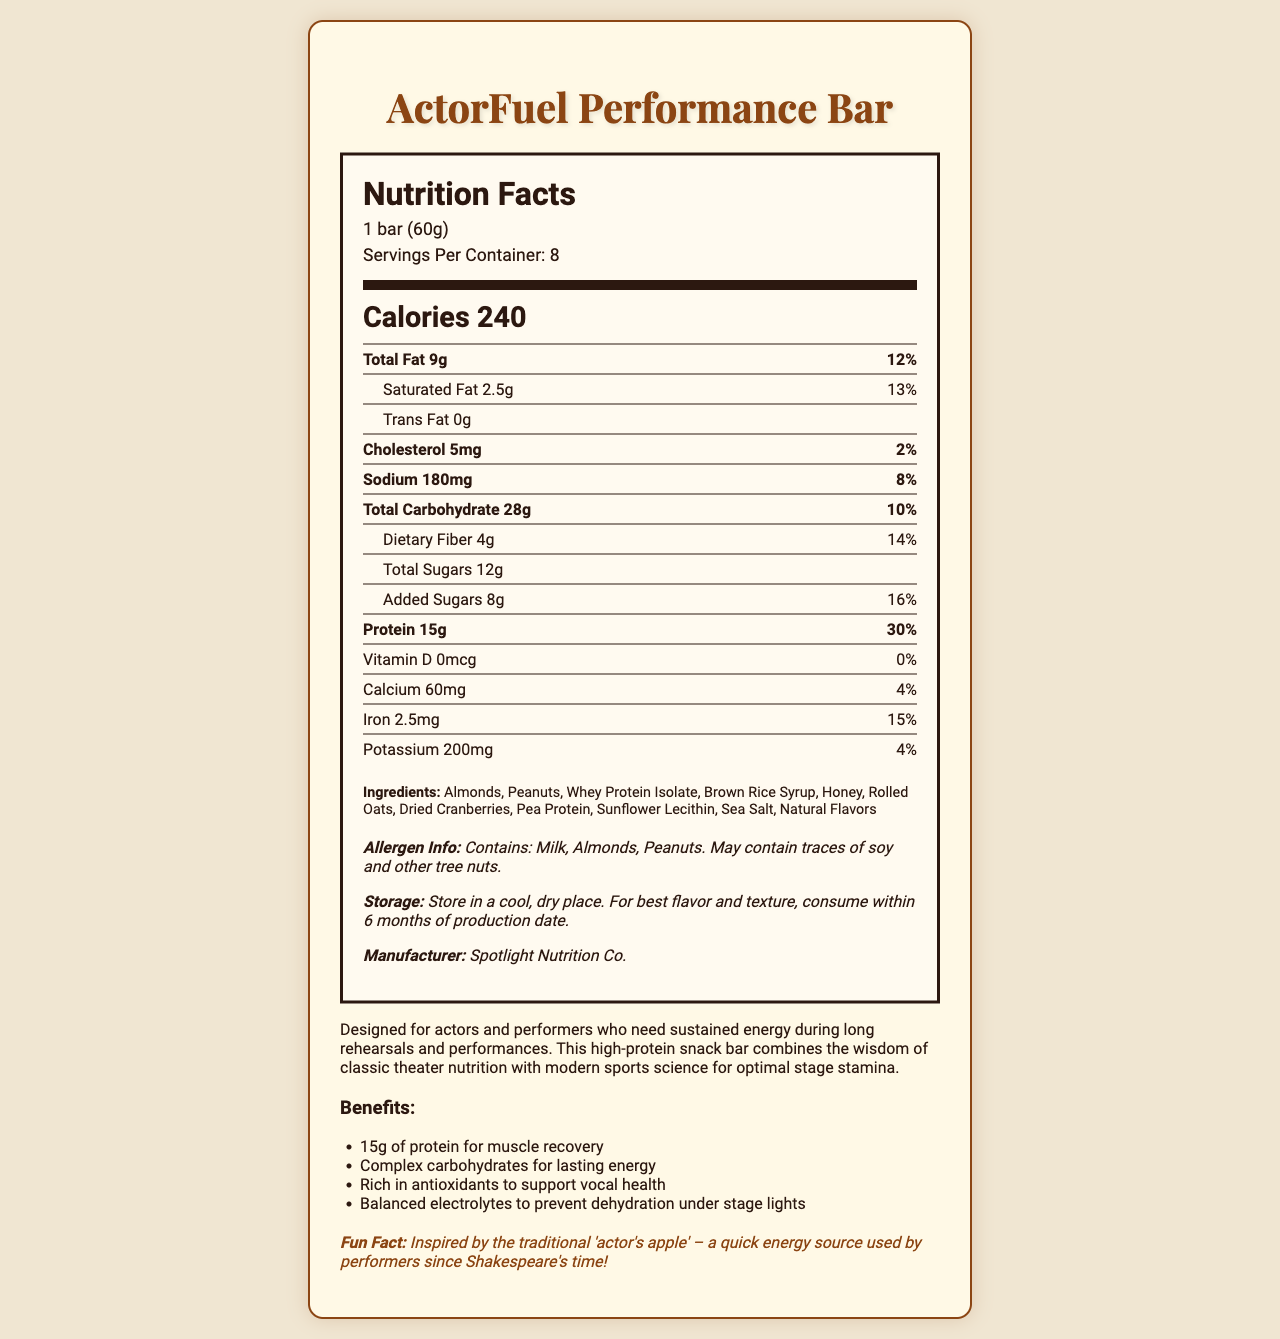what is the serving size for ActorFuel Performance Bar? The serving size is explicitly mentioned as "1 bar (60g)".
Answer: 1 bar (60g) how many calories are there in one serving of the ActorFuel Performance Bar? The document states that one serving contains 240 calories.
Answer: 240 calories how much protein is there in one ActorFuel Performance Bar? The protein content for one serving is listed as 15g.
Answer: 15g how many servings are there per container? The number of servings per container is clearly mentioned as 8.
Answer: 8 what percentage of daily value of dietary fiber does one bar contain? The document shows that one bar contains 14% of the daily value for dietary fiber.
Answer: 14% what is the amount of added sugars in one bar? One bar has 8 grams of added sugars.
Answer: 8g what allergens are present in the ActorFuel Performance Bar? The allergen information states that the bar contains milk, almonds, and peanuts, and may contain traces of soy and other tree nuts.
Answer: Milk, Almonds, Peanuts what is the storage instruction for ActorFuel Performance Bar? The storage instructions are to keep it in a cool, dry place and to consume within six months for the best flavor and texture.
Answer: Store in a cool, dry place. For best flavor and texture, consume within 6 months of production date. which ingredient is listed first in the ingredients of the ActorFuel Performance Bar? A. Honey B. Almonds C. Peanuts The first ingredient listed is Almonds.
Answer: B what is the total amount of fat in one bar? A. 9g B. 2.5g C. 0g The document states that the total fat content is 9g.
Answer: A is there any trans fat in the ActorFuel Performance Bar? The document explicitly states that there are 0 grams of trans fat.
Answer: No what are the benefits of the ActorFuel Performance Bar? The benefits section lists these points explicitly.
Answer: 15g of protein for muscle recovery, Complex carbohydrates for lasting energy, Rich in antioxidants to support vocal health, Balanced electrolytes to prevent dehydration under stage lights can you summarize the main idea of the document? This summary captures the key points such as nutritional details, intended benefits, and additional information found in the document.
Answer: The document provides detailed nutritional information about the ActorFuel Performance Bar, highlighting its high protein content, benefits for performers, ingredients, allergen info, and storage instructions. how many grams of dietary fiber are there in one serving? The document specifies that one serving contains 4 grams of dietary fiber.
Answer: 4g does one ActorFuel Performance Bar contain Vitamin D? The document states that the Vitamin D content is 0mcg, which means there is no Vitamin D in one bar.
Answer: No where is the ActorFuel Performance Bar manufactured? The manufacturer mentioned in the document is Spotlight Nutrition Co.
Answer: Spotlight Nutrition Co. how much sodium does one bar contain? The document lists the sodium content as 180mg per bar.
Answer: 180mg what is the daily value percentage of iron in one bar? The daily value percentage of iron is given as 15%.
Answer: 15% what is the fun fact about ActorFuel Performance Bar? The fun fact is located at the bottom of the document.
Answer: Inspired by the traditional 'actor's apple' – a quick energy source used by performers since Shakespeare's time! are the ingredients of ActorFuel Performance Bar organic? The document does not provide specifics about whether the ingredients are organic.
Answer: Not enough information 